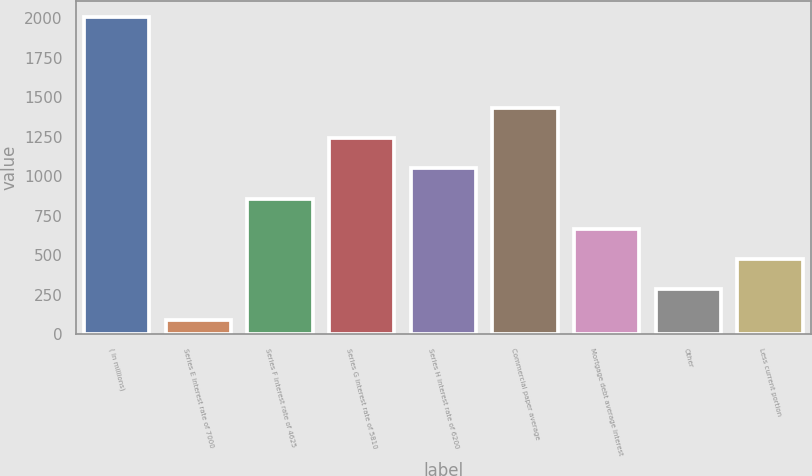<chart> <loc_0><loc_0><loc_500><loc_500><bar_chart><fcel>( in millions)<fcel>Series E interest rate of 7000<fcel>Series F interest rate of 4625<fcel>Series G interest rate of 5810<fcel>Series H interest rate of 6200<fcel>Commercial paper average<fcel>Mortgage debt average interest<fcel>Other<fcel>Less current portion<nl><fcel>2007<fcel>91<fcel>857.4<fcel>1240.6<fcel>1049<fcel>1432.2<fcel>665.8<fcel>282.6<fcel>474.2<nl></chart> 